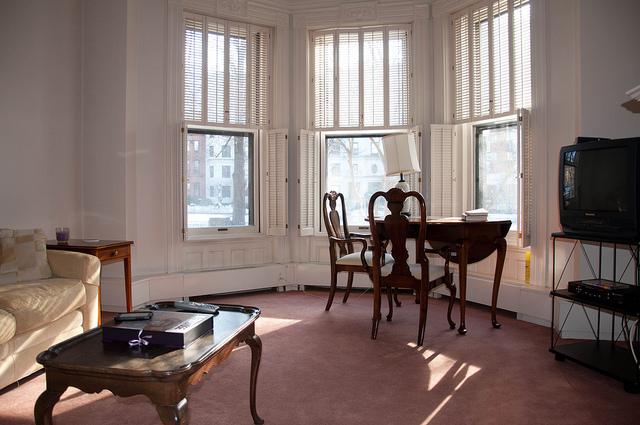Does this window arrangement allow for ample sunlight?
Give a very brief answer. Yes. How many chairs are there?
Write a very short answer. 2. Are the blinds closed?
Write a very short answer. No. Is this a living room?
Concise answer only. Yes. 